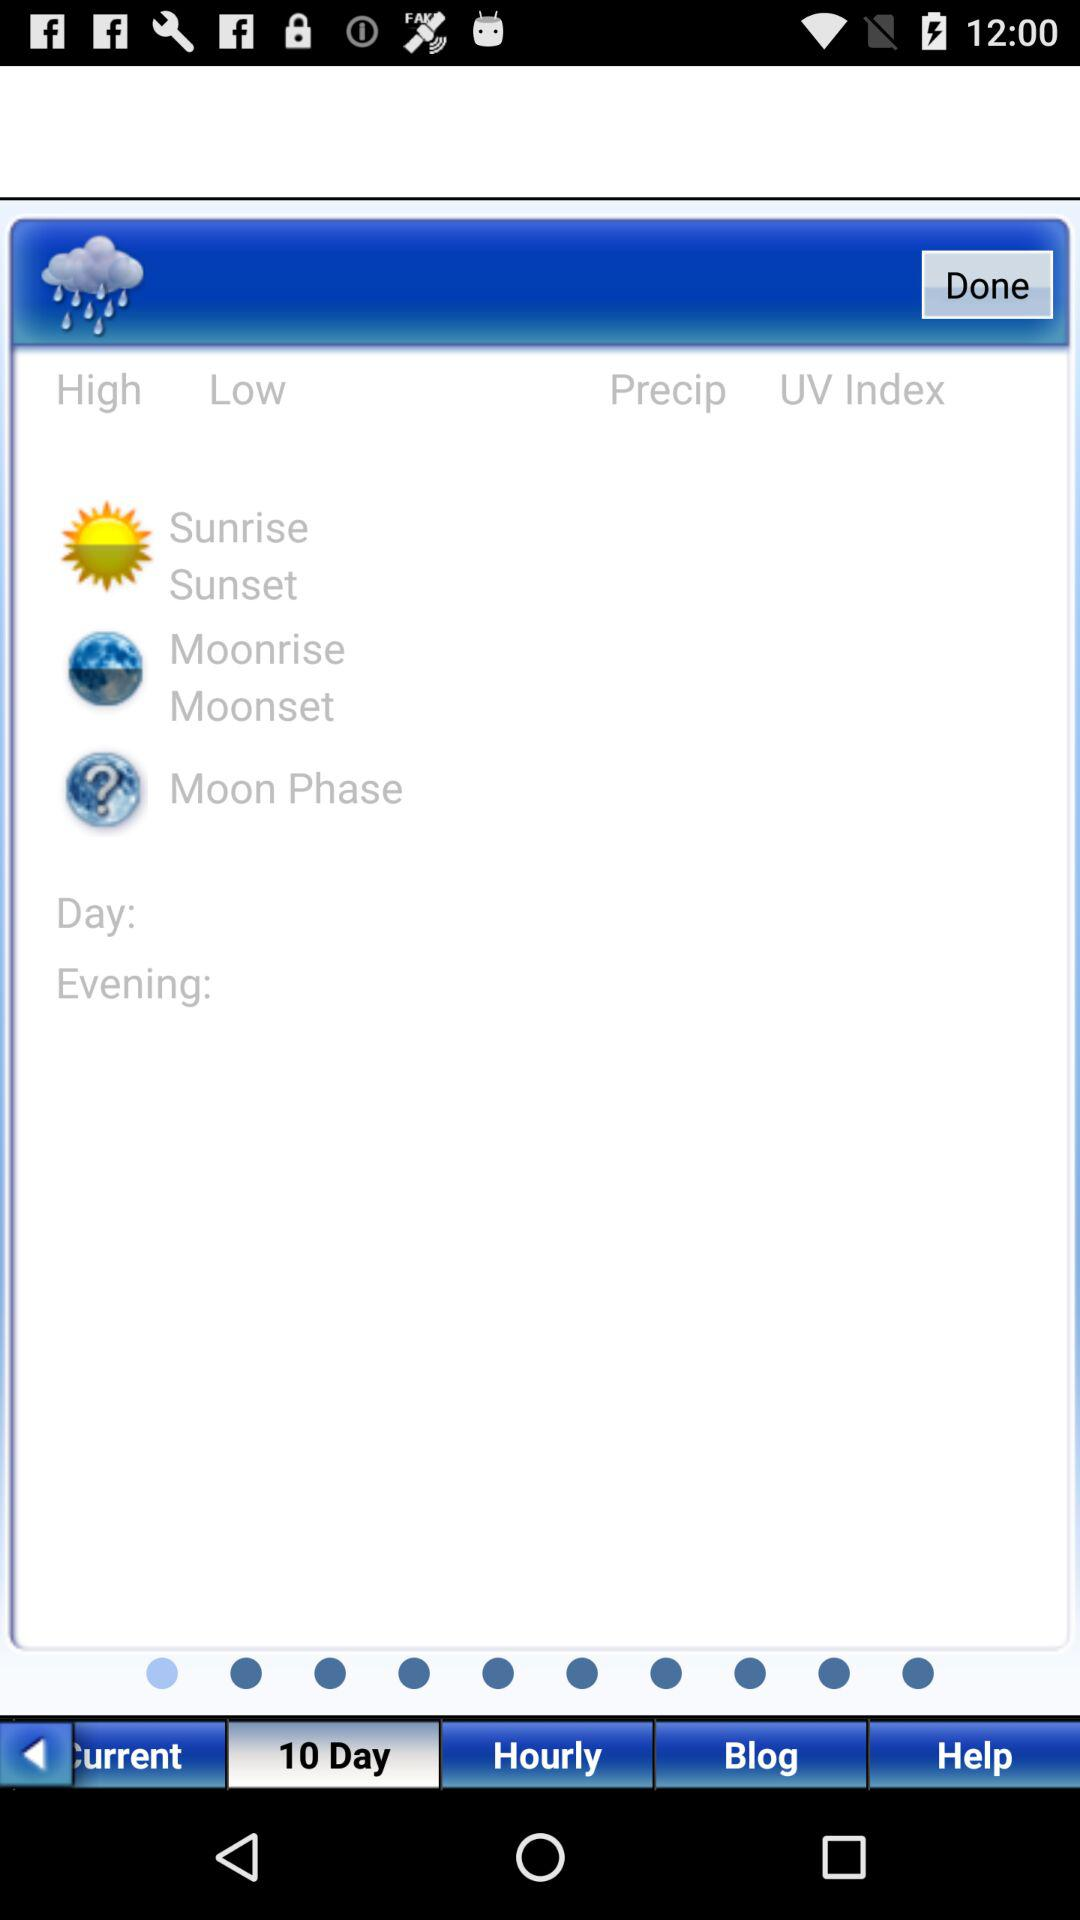Which tab is selected? The selected tab is "10 Day". 